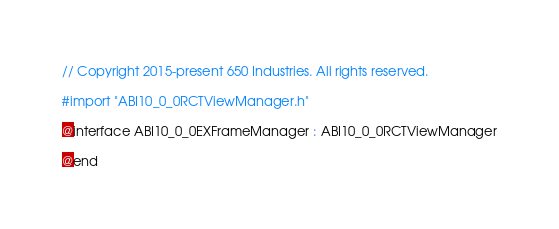Convert code to text. <code><loc_0><loc_0><loc_500><loc_500><_C_>// Copyright 2015-present 650 Industries. All rights reserved.

#import "ABI10_0_0RCTViewManager.h"

@interface ABI10_0_0EXFrameManager : ABI10_0_0RCTViewManager

@end
</code> 